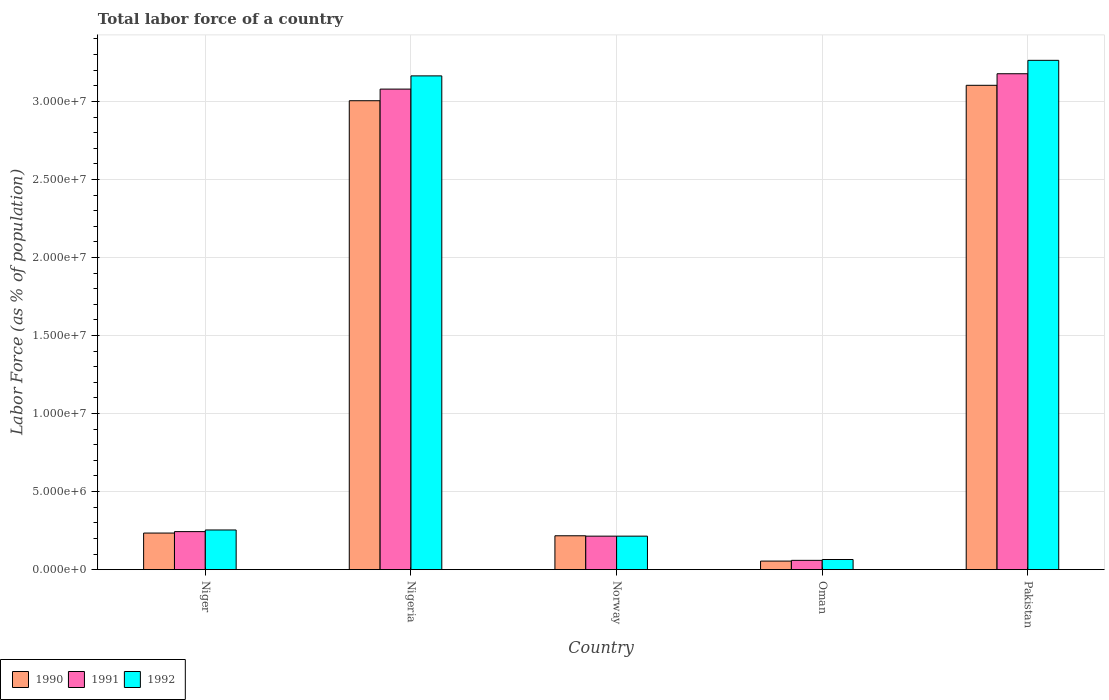Are the number of bars per tick equal to the number of legend labels?
Make the answer very short. Yes. What is the label of the 4th group of bars from the left?
Your answer should be very brief. Oman. What is the percentage of labor force in 1991 in Oman?
Provide a succinct answer. 5.94e+05. Across all countries, what is the maximum percentage of labor force in 1991?
Your answer should be compact. 3.18e+07. Across all countries, what is the minimum percentage of labor force in 1990?
Your answer should be compact. 5.48e+05. In which country was the percentage of labor force in 1990 maximum?
Keep it short and to the point. Pakistan. In which country was the percentage of labor force in 1991 minimum?
Keep it short and to the point. Oman. What is the total percentage of labor force in 1992 in the graph?
Offer a very short reply. 6.96e+07. What is the difference between the percentage of labor force in 1991 in Nigeria and that in Pakistan?
Make the answer very short. -9.84e+05. What is the difference between the percentage of labor force in 1992 in Pakistan and the percentage of labor force in 1990 in Norway?
Your answer should be very brief. 3.05e+07. What is the average percentage of labor force in 1990 per country?
Offer a very short reply. 1.32e+07. What is the difference between the percentage of labor force of/in 1991 and percentage of labor force of/in 1992 in Pakistan?
Offer a very short reply. -8.59e+05. In how many countries, is the percentage of labor force in 1991 greater than 11000000 %?
Give a very brief answer. 2. What is the ratio of the percentage of labor force in 1990 in Nigeria to that in Norway?
Your answer should be compact. 13.85. What is the difference between the highest and the second highest percentage of labor force in 1990?
Keep it short and to the point. -2.77e+07. What is the difference between the highest and the lowest percentage of labor force in 1992?
Ensure brevity in your answer.  3.20e+07. In how many countries, is the percentage of labor force in 1991 greater than the average percentage of labor force in 1991 taken over all countries?
Offer a terse response. 2. Is the sum of the percentage of labor force in 1991 in Niger and Nigeria greater than the maximum percentage of labor force in 1990 across all countries?
Your answer should be very brief. Yes. What does the 2nd bar from the right in Pakistan represents?
Your answer should be compact. 1991. Are all the bars in the graph horizontal?
Keep it short and to the point. No. What is the difference between two consecutive major ticks on the Y-axis?
Make the answer very short. 5.00e+06. Are the values on the major ticks of Y-axis written in scientific E-notation?
Offer a very short reply. Yes. How many legend labels are there?
Your response must be concise. 3. What is the title of the graph?
Provide a short and direct response. Total labor force of a country. Does "2005" appear as one of the legend labels in the graph?
Keep it short and to the point. No. What is the label or title of the Y-axis?
Keep it short and to the point. Labor Force (as % of population). What is the Labor Force (as % of population) of 1990 in Niger?
Provide a succinct answer. 2.34e+06. What is the Labor Force (as % of population) of 1991 in Niger?
Ensure brevity in your answer.  2.44e+06. What is the Labor Force (as % of population) in 1992 in Niger?
Offer a very short reply. 2.54e+06. What is the Labor Force (as % of population) of 1990 in Nigeria?
Provide a short and direct response. 3.00e+07. What is the Labor Force (as % of population) in 1991 in Nigeria?
Give a very brief answer. 3.08e+07. What is the Labor Force (as % of population) in 1992 in Nigeria?
Ensure brevity in your answer.  3.16e+07. What is the Labor Force (as % of population) of 1990 in Norway?
Offer a terse response. 2.17e+06. What is the Labor Force (as % of population) of 1991 in Norway?
Ensure brevity in your answer.  2.14e+06. What is the Labor Force (as % of population) in 1992 in Norway?
Provide a succinct answer. 2.14e+06. What is the Labor Force (as % of population) of 1990 in Oman?
Ensure brevity in your answer.  5.48e+05. What is the Labor Force (as % of population) in 1991 in Oman?
Keep it short and to the point. 5.94e+05. What is the Labor Force (as % of population) of 1992 in Oman?
Your answer should be very brief. 6.48e+05. What is the Labor Force (as % of population) of 1990 in Pakistan?
Your answer should be very brief. 3.10e+07. What is the Labor Force (as % of population) of 1991 in Pakistan?
Give a very brief answer. 3.18e+07. What is the Labor Force (as % of population) in 1992 in Pakistan?
Offer a terse response. 3.26e+07. Across all countries, what is the maximum Labor Force (as % of population) of 1990?
Give a very brief answer. 3.10e+07. Across all countries, what is the maximum Labor Force (as % of population) in 1991?
Your answer should be compact. 3.18e+07. Across all countries, what is the maximum Labor Force (as % of population) in 1992?
Your answer should be compact. 3.26e+07. Across all countries, what is the minimum Labor Force (as % of population) of 1990?
Make the answer very short. 5.48e+05. Across all countries, what is the minimum Labor Force (as % of population) of 1991?
Give a very brief answer. 5.94e+05. Across all countries, what is the minimum Labor Force (as % of population) of 1992?
Give a very brief answer. 6.48e+05. What is the total Labor Force (as % of population) in 1990 in the graph?
Your response must be concise. 6.61e+07. What is the total Labor Force (as % of population) of 1991 in the graph?
Ensure brevity in your answer.  6.77e+07. What is the total Labor Force (as % of population) in 1992 in the graph?
Provide a short and direct response. 6.96e+07. What is the difference between the Labor Force (as % of population) in 1990 in Niger and that in Nigeria?
Your response must be concise. -2.77e+07. What is the difference between the Labor Force (as % of population) of 1991 in Niger and that in Nigeria?
Give a very brief answer. -2.84e+07. What is the difference between the Labor Force (as % of population) in 1992 in Niger and that in Nigeria?
Your answer should be compact. -2.91e+07. What is the difference between the Labor Force (as % of population) of 1990 in Niger and that in Norway?
Your answer should be compact. 1.74e+05. What is the difference between the Labor Force (as % of population) of 1991 in Niger and that in Norway?
Your answer should be compact. 2.91e+05. What is the difference between the Labor Force (as % of population) of 1992 in Niger and that in Norway?
Make the answer very short. 3.96e+05. What is the difference between the Labor Force (as % of population) of 1990 in Niger and that in Oman?
Your answer should be compact. 1.80e+06. What is the difference between the Labor Force (as % of population) in 1991 in Niger and that in Oman?
Your answer should be very brief. 1.84e+06. What is the difference between the Labor Force (as % of population) in 1992 in Niger and that in Oman?
Your response must be concise. 1.89e+06. What is the difference between the Labor Force (as % of population) of 1990 in Niger and that in Pakistan?
Provide a succinct answer. -2.87e+07. What is the difference between the Labor Force (as % of population) in 1991 in Niger and that in Pakistan?
Offer a very short reply. -2.93e+07. What is the difference between the Labor Force (as % of population) of 1992 in Niger and that in Pakistan?
Offer a very short reply. -3.01e+07. What is the difference between the Labor Force (as % of population) of 1990 in Nigeria and that in Norway?
Offer a terse response. 2.79e+07. What is the difference between the Labor Force (as % of population) in 1991 in Nigeria and that in Norway?
Provide a short and direct response. 2.86e+07. What is the difference between the Labor Force (as % of population) in 1992 in Nigeria and that in Norway?
Give a very brief answer. 2.95e+07. What is the difference between the Labor Force (as % of population) in 1990 in Nigeria and that in Oman?
Give a very brief answer. 2.95e+07. What is the difference between the Labor Force (as % of population) in 1991 in Nigeria and that in Oman?
Offer a very short reply. 3.02e+07. What is the difference between the Labor Force (as % of population) in 1992 in Nigeria and that in Oman?
Your answer should be compact. 3.10e+07. What is the difference between the Labor Force (as % of population) in 1990 in Nigeria and that in Pakistan?
Give a very brief answer. -9.88e+05. What is the difference between the Labor Force (as % of population) of 1991 in Nigeria and that in Pakistan?
Offer a terse response. -9.84e+05. What is the difference between the Labor Force (as % of population) in 1992 in Nigeria and that in Pakistan?
Your answer should be compact. -9.96e+05. What is the difference between the Labor Force (as % of population) of 1990 in Norway and that in Oman?
Provide a succinct answer. 1.62e+06. What is the difference between the Labor Force (as % of population) of 1991 in Norway and that in Oman?
Provide a succinct answer. 1.55e+06. What is the difference between the Labor Force (as % of population) of 1992 in Norway and that in Oman?
Keep it short and to the point. 1.50e+06. What is the difference between the Labor Force (as % of population) in 1990 in Norway and that in Pakistan?
Offer a very short reply. -2.89e+07. What is the difference between the Labor Force (as % of population) of 1991 in Norway and that in Pakistan?
Offer a very short reply. -2.96e+07. What is the difference between the Labor Force (as % of population) of 1992 in Norway and that in Pakistan?
Give a very brief answer. -3.05e+07. What is the difference between the Labor Force (as % of population) of 1990 in Oman and that in Pakistan?
Your response must be concise. -3.05e+07. What is the difference between the Labor Force (as % of population) of 1991 in Oman and that in Pakistan?
Your response must be concise. -3.12e+07. What is the difference between the Labor Force (as % of population) of 1992 in Oman and that in Pakistan?
Your answer should be very brief. -3.20e+07. What is the difference between the Labor Force (as % of population) of 1990 in Niger and the Labor Force (as % of population) of 1991 in Nigeria?
Your answer should be very brief. -2.84e+07. What is the difference between the Labor Force (as % of population) of 1990 in Niger and the Labor Force (as % of population) of 1992 in Nigeria?
Give a very brief answer. -2.93e+07. What is the difference between the Labor Force (as % of population) of 1991 in Niger and the Labor Force (as % of population) of 1992 in Nigeria?
Ensure brevity in your answer.  -2.92e+07. What is the difference between the Labor Force (as % of population) in 1990 in Niger and the Labor Force (as % of population) in 1991 in Norway?
Offer a very short reply. 1.99e+05. What is the difference between the Labor Force (as % of population) of 1990 in Niger and the Labor Force (as % of population) of 1992 in Norway?
Your response must be concise. 1.99e+05. What is the difference between the Labor Force (as % of population) in 1991 in Niger and the Labor Force (as % of population) in 1992 in Norway?
Offer a terse response. 2.91e+05. What is the difference between the Labor Force (as % of population) of 1990 in Niger and the Labor Force (as % of population) of 1991 in Oman?
Your answer should be very brief. 1.75e+06. What is the difference between the Labor Force (as % of population) of 1990 in Niger and the Labor Force (as % of population) of 1992 in Oman?
Make the answer very short. 1.69e+06. What is the difference between the Labor Force (as % of population) in 1991 in Niger and the Labor Force (as % of population) in 1992 in Oman?
Ensure brevity in your answer.  1.79e+06. What is the difference between the Labor Force (as % of population) of 1990 in Niger and the Labor Force (as % of population) of 1991 in Pakistan?
Keep it short and to the point. -2.94e+07. What is the difference between the Labor Force (as % of population) of 1990 in Niger and the Labor Force (as % of population) of 1992 in Pakistan?
Offer a terse response. -3.03e+07. What is the difference between the Labor Force (as % of population) in 1991 in Niger and the Labor Force (as % of population) in 1992 in Pakistan?
Offer a very short reply. -3.02e+07. What is the difference between the Labor Force (as % of population) of 1990 in Nigeria and the Labor Force (as % of population) of 1991 in Norway?
Offer a terse response. 2.79e+07. What is the difference between the Labor Force (as % of population) of 1990 in Nigeria and the Labor Force (as % of population) of 1992 in Norway?
Offer a terse response. 2.79e+07. What is the difference between the Labor Force (as % of population) of 1991 in Nigeria and the Labor Force (as % of population) of 1992 in Norway?
Offer a very short reply. 2.86e+07. What is the difference between the Labor Force (as % of population) in 1990 in Nigeria and the Labor Force (as % of population) in 1991 in Oman?
Your response must be concise. 2.94e+07. What is the difference between the Labor Force (as % of population) of 1990 in Nigeria and the Labor Force (as % of population) of 1992 in Oman?
Your answer should be very brief. 2.94e+07. What is the difference between the Labor Force (as % of population) of 1991 in Nigeria and the Labor Force (as % of population) of 1992 in Oman?
Give a very brief answer. 3.01e+07. What is the difference between the Labor Force (as % of population) of 1990 in Nigeria and the Labor Force (as % of population) of 1991 in Pakistan?
Ensure brevity in your answer.  -1.73e+06. What is the difference between the Labor Force (as % of population) in 1990 in Nigeria and the Labor Force (as % of population) in 1992 in Pakistan?
Keep it short and to the point. -2.59e+06. What is the difference between the Labor Force (as % of population) in 1991 in Nigeria and the Labor Force (as % of population) in 1992 in Pakistan?
Offer a terse response. -1.84e+06. What is the difference between the Labor Force (as % of population) in 1990 in Norway and the Labor Force (as % of population) in 1991 in Oman?
Keep it short and to the point. 1.57e+06. What is the difference between the Labor Force (as % of population) of 1990 in Norway and the Labor Force (as % of population) of 1992 in Oman?
Provide a succinct answer. 1.52e+06. What is the difference between the Labor Force (as % of population) of 1991 in Norway and the Labor Force (as % of population) of 1992 in Oman?
Make the answer very short. 1.50e+06. What is the difference between the Labor Force (as % of population) of 1990 in Norway and the Labor Force (as % of population) of 1991 in Pakistan?
Offer a terse response. -2.96e+07. What is the difference between the Labor Force (as % of population) in 1990 in Norway and the Labor Force (as % of population) in 1992 in Pakistan?
Your answer should be very brief. -3.05e+07. What is the difference between the Labor Force (as % of population) in 1991 in Norway and the Labor Force (as % of population) in 1992 in Pakistan?
Your answer should be very brief. -3.05e+07. What is the difference between the Labor Force (as % of population) of 1990 in Oman and the Labor Force (as % of population) of 1991 in Pakistan?
Your response must be concise. -3.12e+07. What is the difference between the Labor Force (as % of population) of 1990 in Oman and the Labor Force (as % of population) of 1992 in Pakistan?
Keep it short and to the point. -3.21e+07. What is the difference between the Labor Force (as % of population) of 1991 in Oman and the Labor Force (as % of population) of 1992 in Pakistan?
Keep it short and to the point. -3.20e+07. What is the average Labor Force (as % of population) of 1990 per country?
Ensure brevity in your answer.  1.32e+07. What is the average Labor Force (as % of population) in 1991 per country?
Offer a terse response. 1.35e+07. What is the average Labor Force (as % of population) of 1992 per country?
Make the answer very short. 1.39e+07. What is the difference between the Labor Force (as % of population) in 1990 and Labor Force (as % of population) in 1991 in Niger?
Your answer should be compact. -9.19e+04. What is the difference between the Labor Force (as % of population) in 1990 and Labor Force (as % of population) in 1992 in Niger?
Provide a short and direct response. -1.97e+05. What is the difference between the Labor Force (as % of population) of 1991 and Labor Force (as % of population) of 1992 in Niger?
Provide a short and direct response. -1.05e+05. What is the difference between the Labor Force (as % of population) of 1990 and Labor Force (as % of population) of 1991 in Nigeria?
Your response must be concise. -7.44e+05. What is the difference between the Labor Force (as % of population) of 1990 and Labor Force (as % of population) of 1992 in Nigeria?
Your answer should be compact. -1.59e+06. What is the difference between the Labor Force (as % of population) in 1991 and Labor Force (as % of population) in 1992 in Nigeria?
Give a very brief answer. -8.47e+05. What is the difference between the Labor Force (as % of population) in 1990 and Labor Force (as % of population) in 1991 in Norway?
Offer a terse response. 2.47e+04. What is the difference between the Labor Force (as % of population) in 1990 and Labor Force (as % of population) in 1992 in Norway?
Provide a short and direct response. 2.48e+04. What is the difference between the Labor Force (as % of population) of 1990 and Labor Force (as % of population) of 1991 in Oman?
Your answer should be very brief. -4.68e+04. What is the difference between the Labor Force (as % of population) of 1990 and Labor Force (as % of population) of 1992 in Oman?
Ensure brevity in your answer.  -1.01e+05. What is the difference between the Labor Force (as % of population) of 1991 and Labor Force (as % of population) of 1992 in Oman?
Your response must be concise. -5.39e+04. What is the difference between the Labor Force (as % of population) of 1990 and Labor Force (as % of population) of 1991 in Pakistan?
Provide a short and direct response. -7.40e+05. What is the difference between the Labor Force (as % of population) of 1990 and Labor Force (as % of population) of 1992 in Pakistan?
Offer a very short reply. -1.60e+06. What is the difference between the Labor Force (as % of population) in 1991 and Labor Force (as % of population) in 1992 in Pakistan?
Give a very brief answer. -8.59e+05. What is the ratio of the Labor Force (as % of population) in 1990 in Niger to that in Nigeria?
Offer a very short reply. 0.08. What is the ratio of the Labor Force (as % of population) in 1991 in Niger to that in Nigeria?
Provide a succinct answer. 0.08. What is the ratio of the Labor Force (as % of population) of 1992 in Niger to that in Nigeria?
Make the answer very short. 0.08. What is the ratio of the Labor Force (as % of population) of 1990 in Niger to that in Norway?
Make the answer very short. 1.08. What is the ratio of the Labor Force (as % of population) of 1991 in Niger to that in Norway?
Offer a terse response. 1.14. What is the ratio of the Labor Force (as % of population) of 1992 in Niger to that in Norway?
Provide a succinct answer. 1.18. What is the ratio of the Labor Force (as % of population) of 1990 in Niger to that in Oman?
Ensure brevity in your answer.  4.28. What is the ratio of the Labor Force (as % of population) in 1991 in Niger to that in Oman?
Offer a very short reply. 4.1. What is the ratio of the Labor Force (as % of population) in 1992 in Niger to that in Oman?
Your response must be concise. 3.92. What is the ratio of the Labor Force (as % of population) in 1990 in Niger to that in Pakistan?
Your answer should be very brief. 0.08. What is the ratio of the Labor Force (as % of population) in 1991 in Niger to that in Pakistan?
Your response must be concise. 0.08. What is the ratio of the Labor Force (as % of population) of 1992 in Niger to that in Pakistan?
Provide a succinct answer. 0.08. What is the ratio of the Labor Force (as % of population) of 1990 in Nigeria to that in Norway?
Ensure brevity in your answer.  13.85. What is the ratio of the Labor Force (as % of population) in 1991 in Nigeria to that in Norway?
Make the answer very short. 14.36. What is the ratio of the Labor Force (as % of population) of 1992 in Nigeria to that in Norway?
Your response must be concise. 14.75. What is the ratio of the Labor Force (as % of population) in 1990 in Nigeria to that in Oman?
Keep it short and to the point. 54.86. What is the ratio of the Labor Force (as % of population) in 1991 in Nigeria to that in Oman?
Your answer should be compact. 51.79. What is the ratio of the Labor Force (as % of population) in 1992 in Nigeria to that in Oman?
Give a very brief answer. 48.79. What is the ratio of the Labor Force (as % of population) of 1990 in Nigeria to that in Pakistan?
Offer a very short reply. 0.97. What is the ratio of the Labor Force (as % of population) of 1992 in Nigeria to that in Pakistan?
Offer a terse response. 0.97. What is the ratio of the Labor Force (as % of population) in 1990 in Norway to that in Oman?
Offer a terse response. 3.96. What is the ratio of the Labor Force (as % of population) in 1991 in Norway to that in Oman?
Make the answer very short. 3.61. What is the ratio of the Labor Force (as % of population) in 1992 in Norway to that in Oman?
Make the answer very short. 3.31. What is the ratio of the Labor Force (as % of population) of 1990 in Norway to that in Pakistan?
Provide a succinct answer. 0.07. What is the ratio of the Labor Force (as % of population) of 1991 in Norway to that in Pakistan?
Provide a short and direct response. 0.07. What is the ratio of the Labor Force (as % of population) in 1992 in Norway to that in Pakistan?
Ensure brevity in your answer.  0.07. What is the ratio of the Labor Force (as % of population) in 1990 in Oman to that in Pakistan?
Ensure brevity in your answer.  0.02. What is the ratio of the Labor Force (as % of population) in 1991 in Oman to that in Pakistan?
Give a very brief answer. 0.02. What is the ratio of the Labor Force (as % of population) in 1992 in Oman to that in Pakistan?
Provide a succinct answer. 0.02. What is the difference between the highest and the second highest Labor Force (as % of population) in 1990?
Make the answer very short. 9.88e+05. What is the difference between the highest and the second highest Labor Force (as % of population) in 1991?
Your answer should be compact. 9.84e+05. What is the difference between the highest and the second highest Labor Force (as % of population) in 1992?
Give a very brief answer. 9.96e+05. What is the difference between the highest and the lowest Labor Force (as % of population) of 1990?
Your answer should be compact. 3.05e+07. What is the difference between the highest and the lowest Labor Force (as % of population) of 1991?
Your response must be concise. 3.12e+07. What is the difference between the highest and the lowest Labor Force (as % of population) in 1992?
Give a very brief answer. 3.20e+07. 